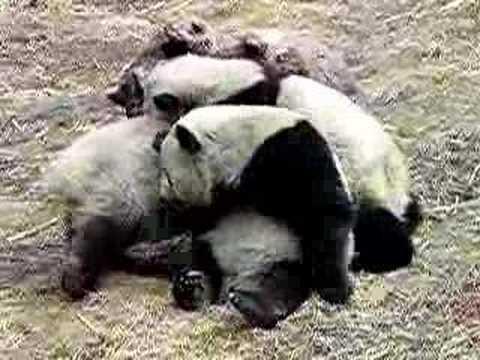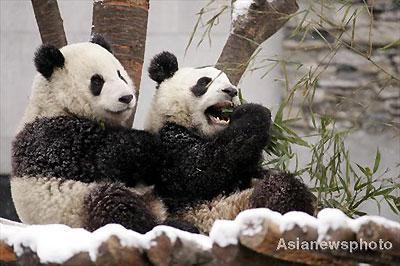The first image is the image on the left, the second image is the image on the right. For the images shown, is this caption "there are two pandas in front of a tree trunk" true? Answer yes or no. Yes. 